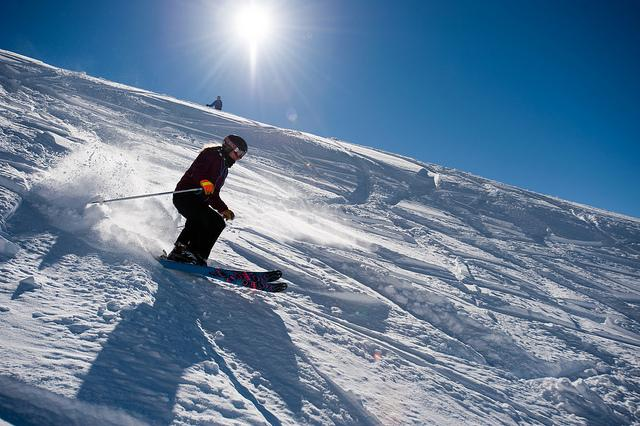Which EU country might be associated with the colors of the skier's gloves? Please explain your reasoning. netherlands. The country is the netherlands. 